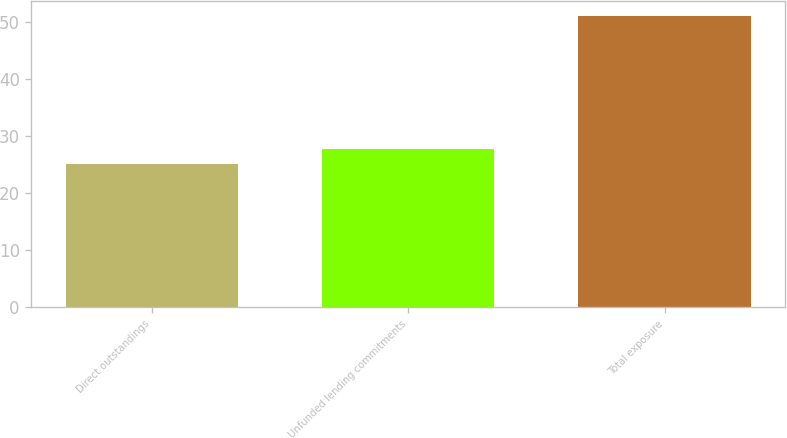Convert chart. <chart><loc_0><loc_0><loc_500><loc_500><bar_chart><fcel>Direct outstandings<fcel>Unfunded lending commitments<fcel>Total exposure<nl><fcel>25<fcel>27.6<fcel>51<nl></chart> 